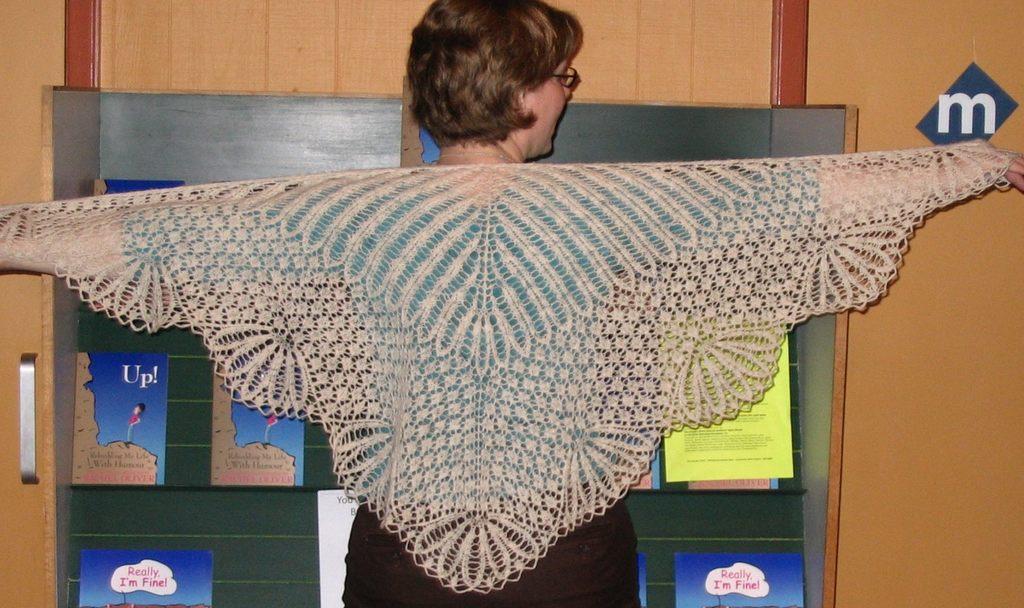Please provide a concise description of this image. In this picture we can see a woman. There are posters on the board. In the background we can see a wooden wall and a handle. 